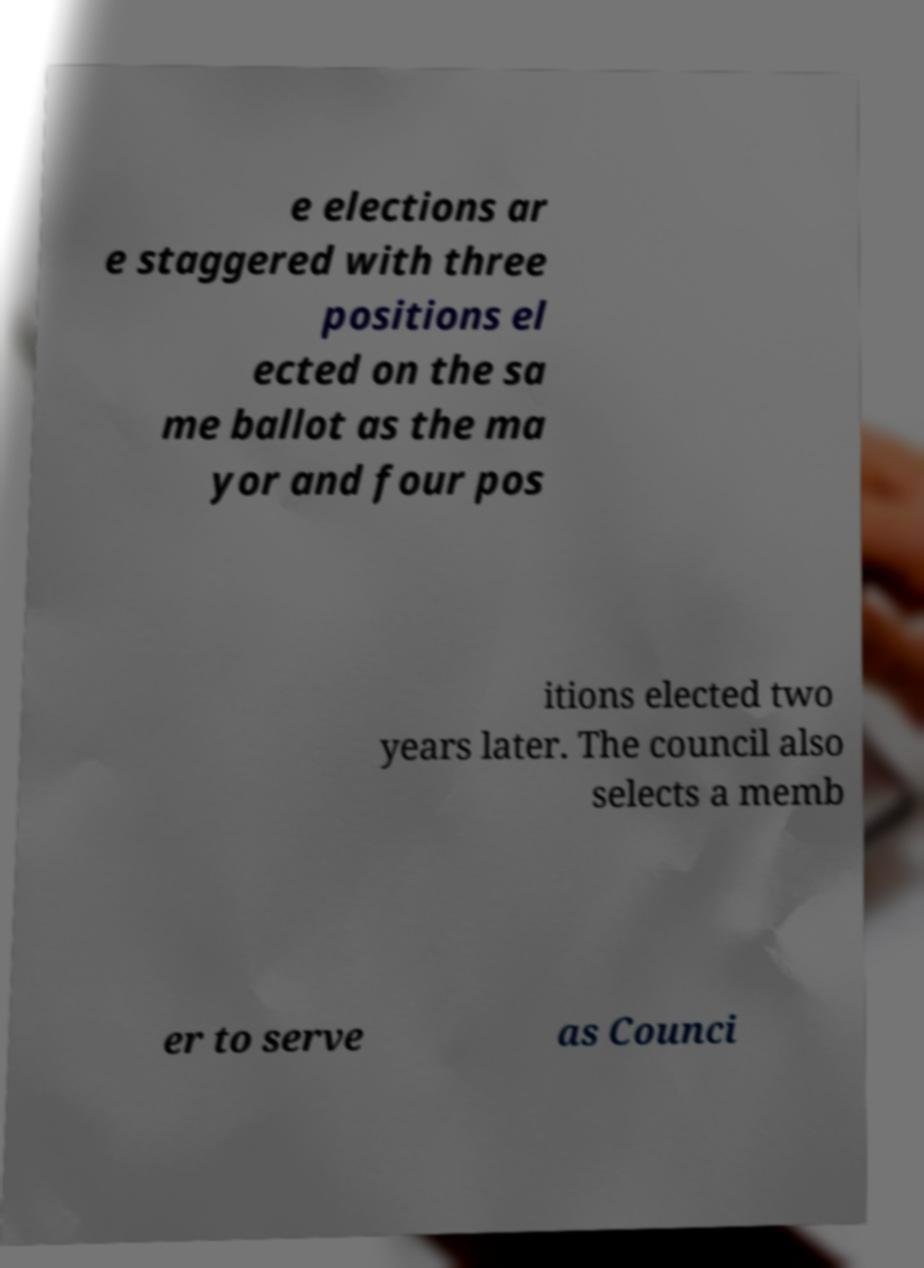Can you accurately transcribe the text from the provided image for me? e elections ar e staggered with three positions el ected on the sa me ballot as the ma yor and four pos itions elected two years later. The council also selects a memb er to serve as Counci 